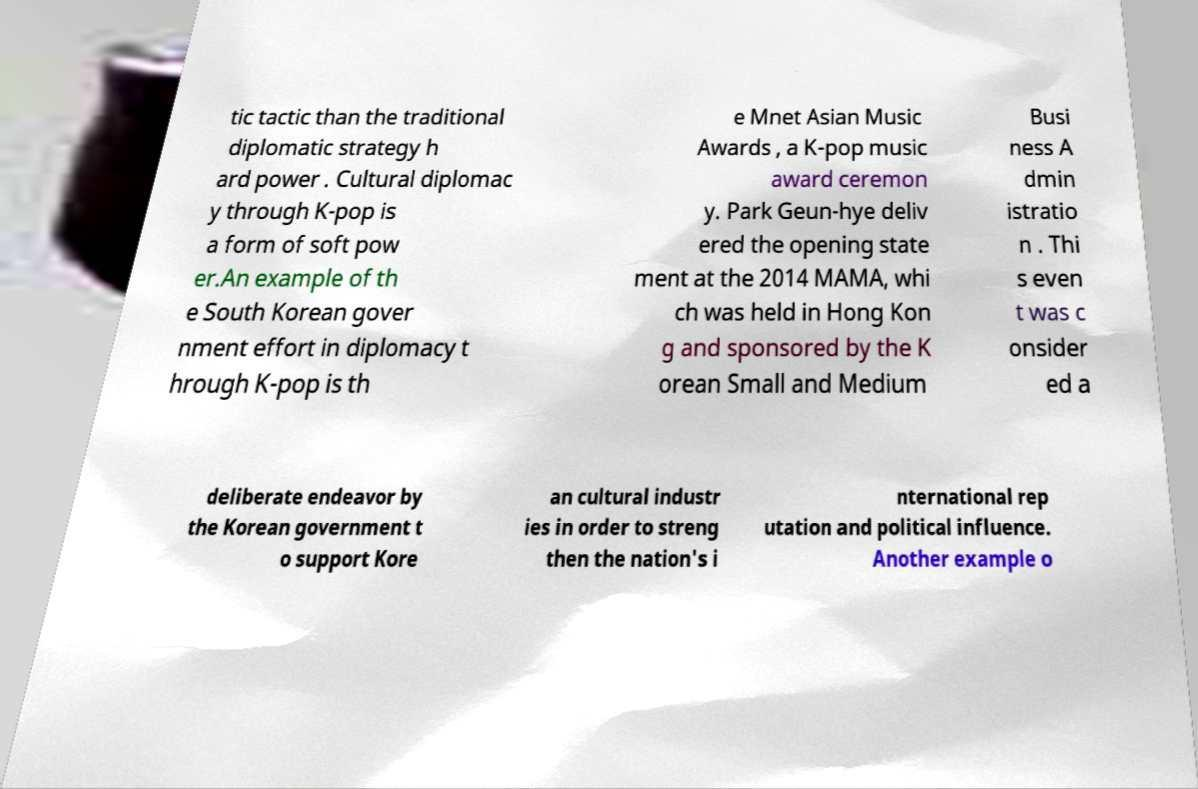For documentation purposes, I need the text within this image transcribed. Could you provide that? tic tactic than the traditional diplomatic strategy h ard power . Cultural diplomac y through K-pop is a form of soft pow er.An example of th e South Korean gover nment effort in diplomacy t hrough K-pop is th e Mnet Asian Music Awards , a K-pop music award ceremon y. Park Geun-hye deliv ered the opening state ment at the 2014 MAMA, whi ch was held in Hong Kon g and sponsored by the K orean Small and Medium Busi ness A dmin istratio n . Thi s even t was c onsider ed a deliberate endeavor by the Korean government t o support Kore an cultural industr ies in order to streng then the nation's i nternational rep utation and political influence. Another example o 